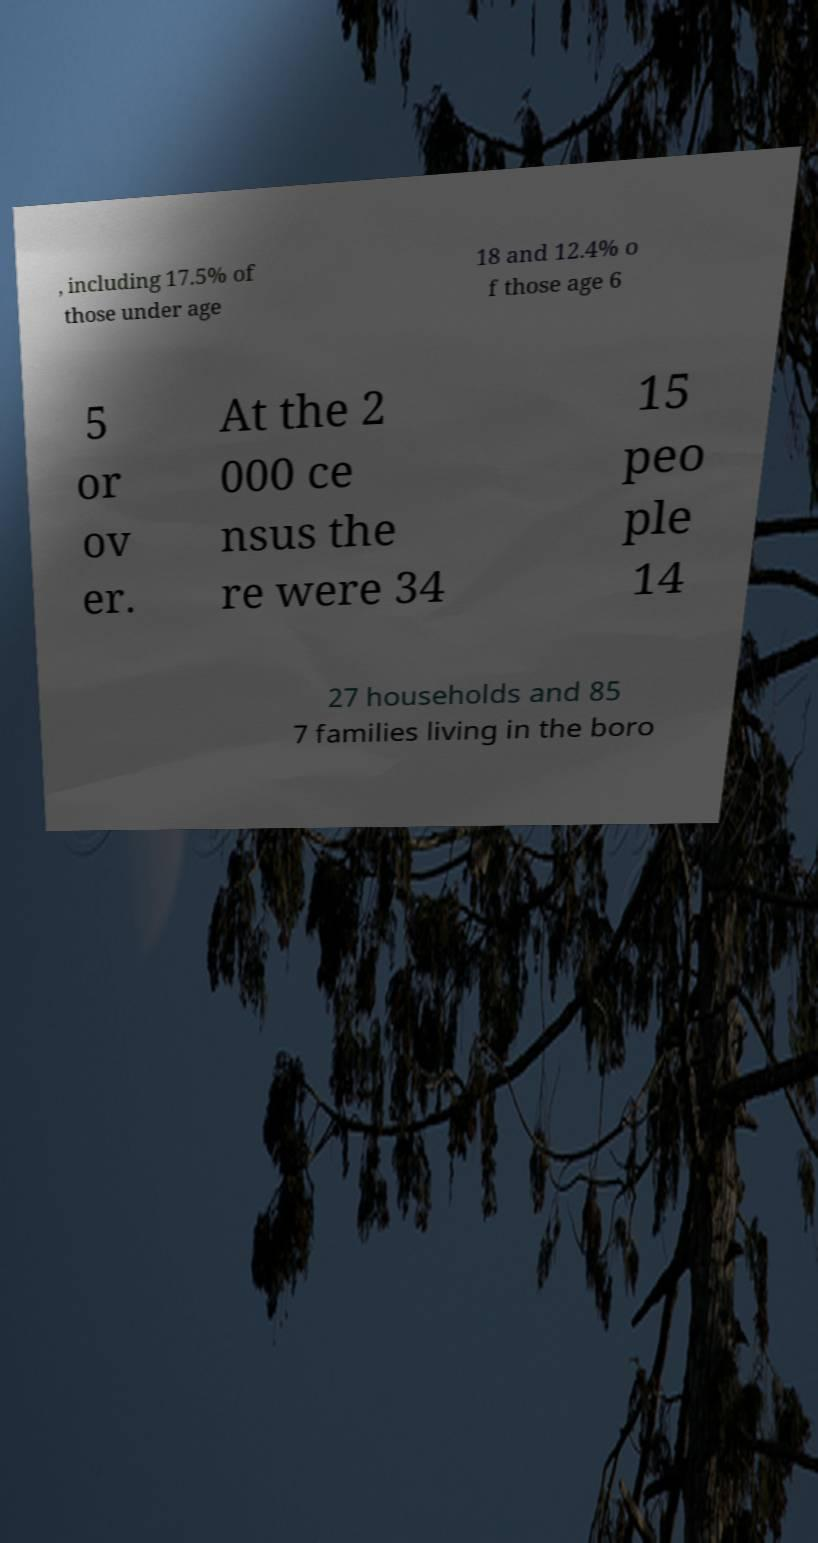What messages or text are displayed in this image? I need them in a readable, typed format. , including 17.5% of those under age 18 and 12.4% o f those age 6 5 or ov er. At the 2 000 ce nsus the re were 34 15 peo ple 14 27 households and 85 7 families living in the boro 